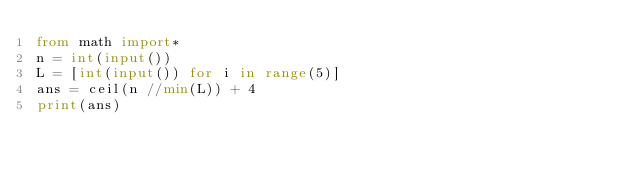Convert code to text. <code><loc_0><loc_0><loc_500><loc_500><_Python_>from math import*
n = int(input())
L = [int(input()) for i in range(5)]
ans = ceil(n //min(L)) + 4
print(ans)
</code> 